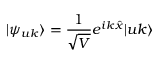Convert formula to latex. <formula><loc_0><loc_0><loc_500><loc_500>| \psi _ { u k } \rangle = \frac { 1 } { \sqrt { V } } e ^ { i k \hat { x } } | u k \rangle</formula> 